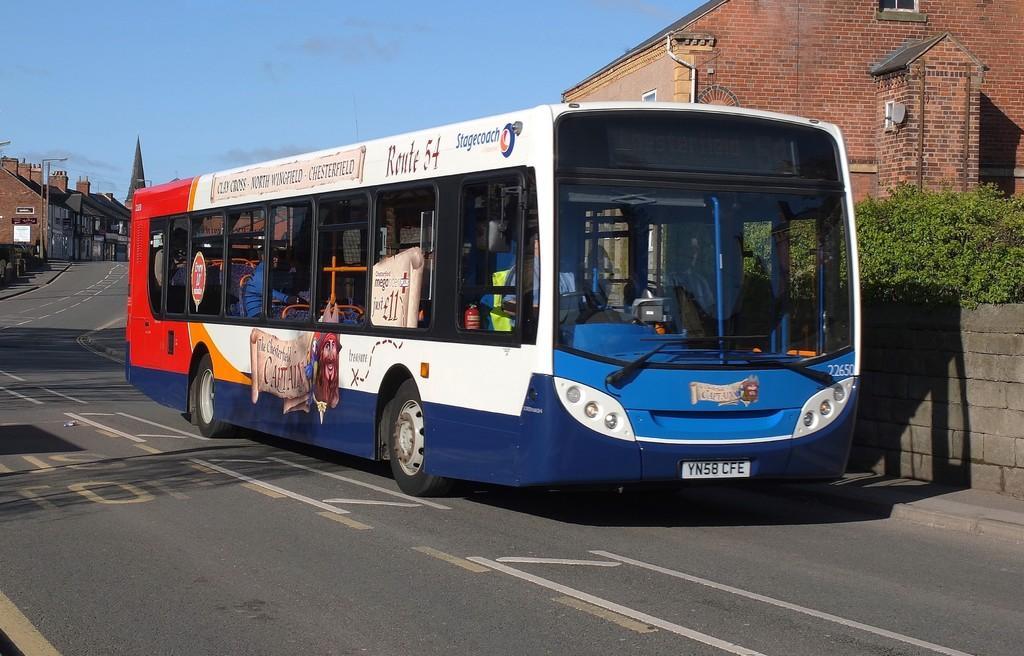In one or two sentences, can you explain what this image depicts? In the center of the image we can see a man is driving a bus and also we can see some people are sitting in the bus. In the background of the image we can see the buildings, poles, lights, pipes, tower, plants, wall and road. At the top of the image we can see the sky. 